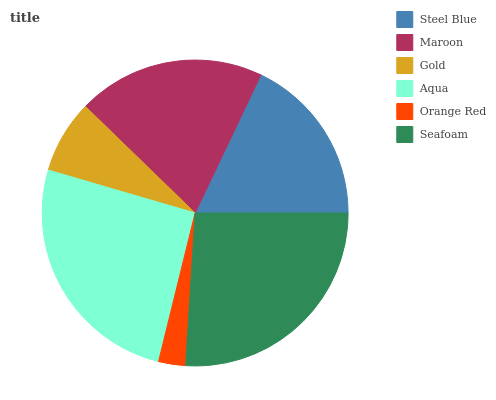Is Orange Red the minimum?
Answer yes or no. Yes. Is Seafoam the maximum?
Answer yes or no. Yes. Is Maroon the minimum?
Answer yes or no. No. Is Maroon the maximum?
Answer yes or no. No. Is Maroon greater than Steel Blue?
Answer yes or no. Yes. Is Steel Blue less than Maroon?
Answer yes or no. Yes. Is Steel Blue greater than Maroon?
Answer yes or no. No. Is Maroon less than Steel Blue?
Answer yes or no. No. Is Maroon the high median?
Answer yes or no. Yes. Is Steel Blue the low median?
Answer yes or no. Yes. Is Seafoam the high median?
Answer yes or no. No. Is Gold the low median?
Answer yes or no. No. 